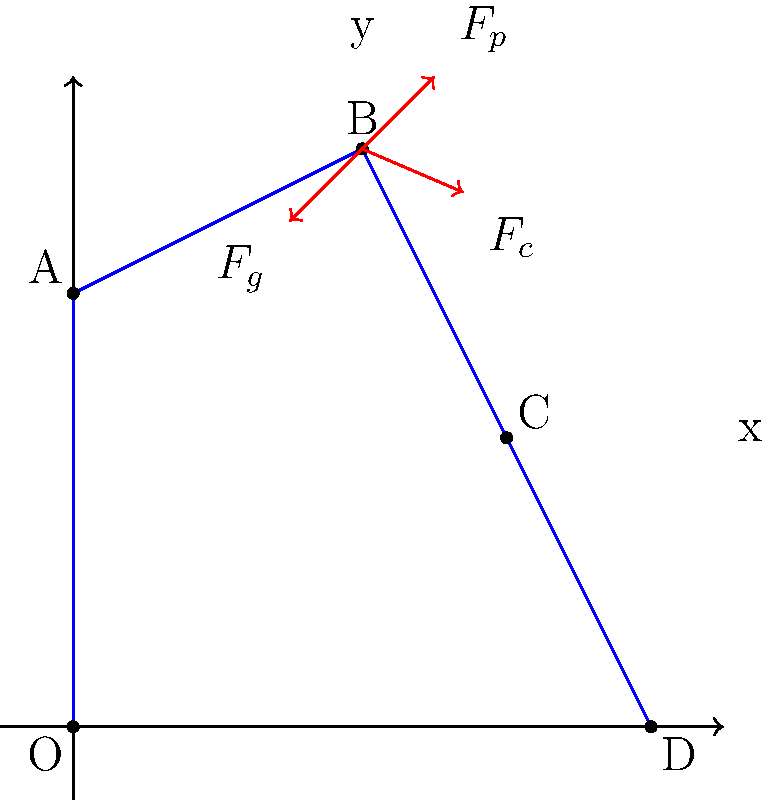As a former track and field athlete, you understand the importance of force analysis in pole vaulting. Consider the force diagram shown for a pole vaulter at the highest point of their jump (point B). Which force is primarily responsible for the vaulter's forward motion at this point? To answer this question, let's analyze the forces acting on the pole vaulter at point B:

1. $F_g$: Gravitational force (weight) - This force always acts downward due to Earth's gravity.

2. $F_p$: Pole force - This is the force exerted by the pole on the vaulter, which is mainly responsible for lifting the vaulter upward.

3. $F_c$: Centripetal force - This force is responsible for the circular motion of the vaulter around the top of the pole.

At the highest point of the jump (point B):

1. The vaulter's vertical velocity is momentarily zero.
2. The gravitational force ($F_g$) and the vertical component of the pole force ($F_p$) are balanced.
3. The horizontal component of the pole force ($F_p$) is minimal at this point.
4. The centripetal force ($F_c$) is still acting on the vaulter, causing them to continue their rotation around the top of the pole.

The centripetal force ($F_c$) is what gives the vaulter their forward motion at this point. It's this force that allows the athlete to continue their rotation and eventually clear the bar.

In pole vaulting, the initial run-up and plant provide the initial forward momentum, but it's the centripetal force at the top of the vault that maintains the forward motion, allowing the vaulter to clear the bar and land safely on the other side.
Answer: Centripetal force ($F_c$) 